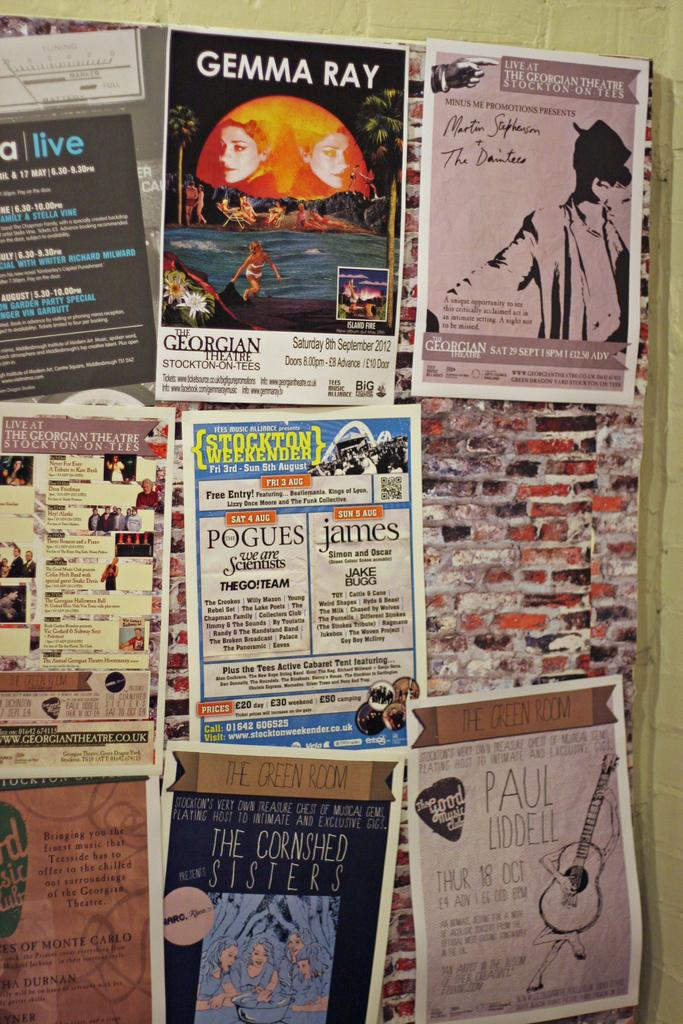<image>
Give a short and clear explanation of the subsequent image. A bulletin board with multiple advertisements attached to it including one with info about Gemma Ray and Paul Liddell. 